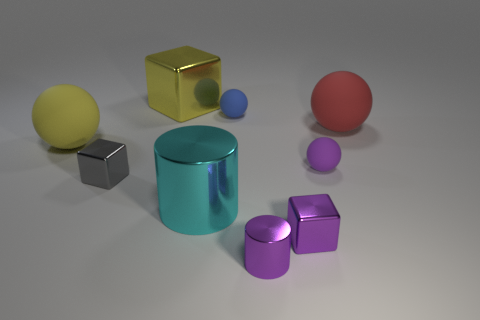Does the large matte object on the right side of the tiny purple shiny block have the same color as the big metallic cube? No, the large matte object on the right side of the tiny purple shiny block does not have the same color as the big metallic cube. The large matte object is a muted orange-yellow color, while the big metallic cube has a bright reflective gold color. The difference in material properties also affects the perception of their colors, with the matte object having a more diffuse appearance and the metallic cube appearing shiny and reflective. 